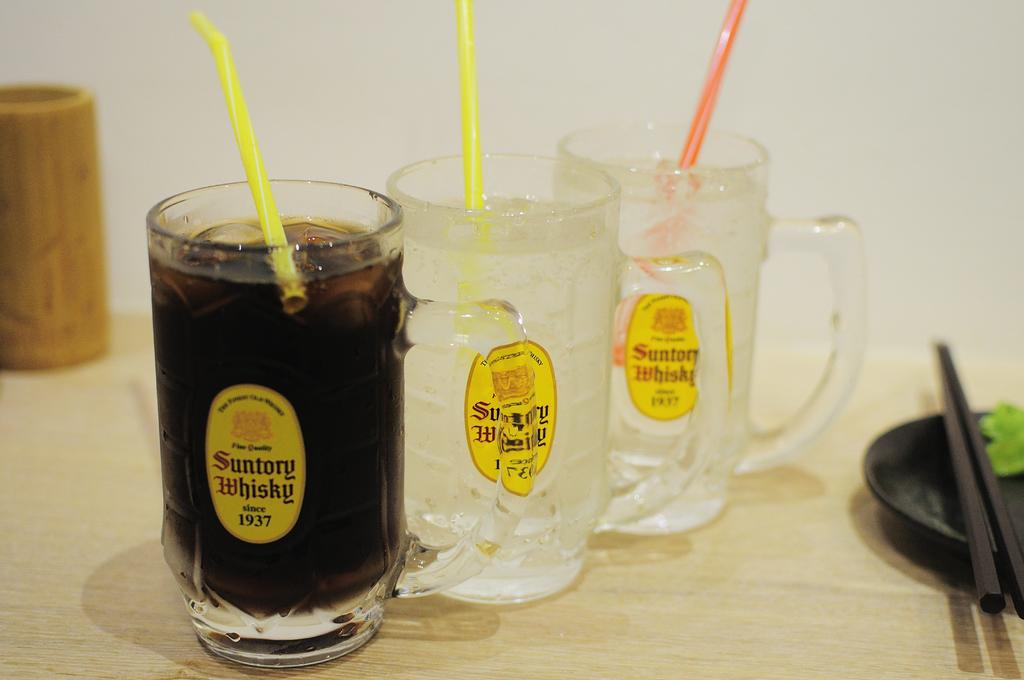How many juice glasses are visible in the image? There are three juice glasses in the image. What is inside the juice glasses? The juice glasses have straws in them. What else can be seen on the table in the image? There is a plate in the image. What utensils are present in the image? There are chopsticks in the image. What type of ray is protesting against the industry in the image? There is no ray, protest, or industry present in the image. 